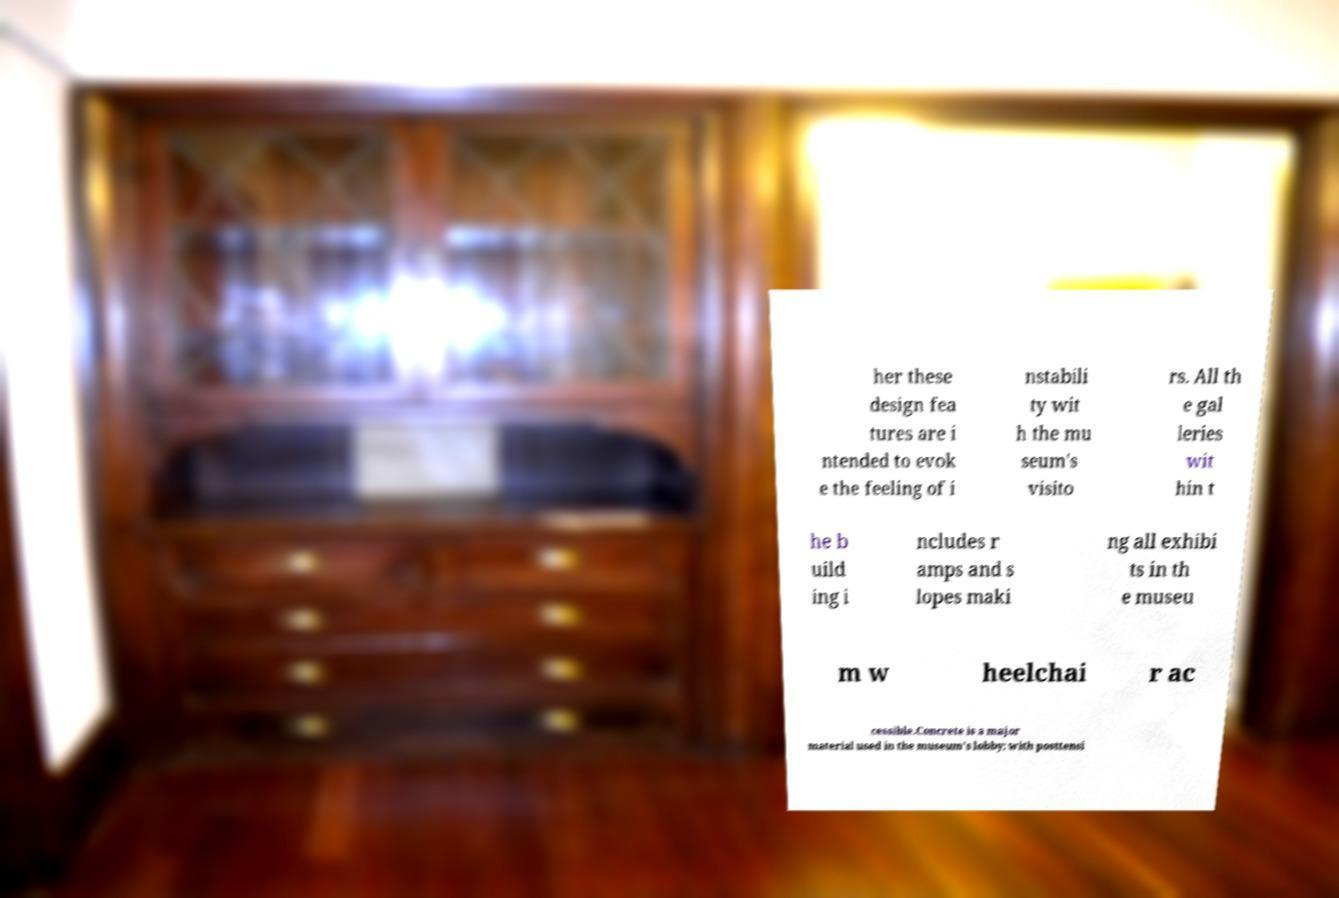For documentation purposes, I need the text within this image transcribed. Could you provide that? her these design fea tures are i ntended to evok e the feeling of i nstabili ty wit h the mu seum's visito rs. All th e gal leries wit hin t he b uild ing i ncludes r amps and s lopes maki ng all exhibi ts in th e museu m w heelchai r ac cessible.Concrete is a major material used in the museum's lobby; with posttensi 